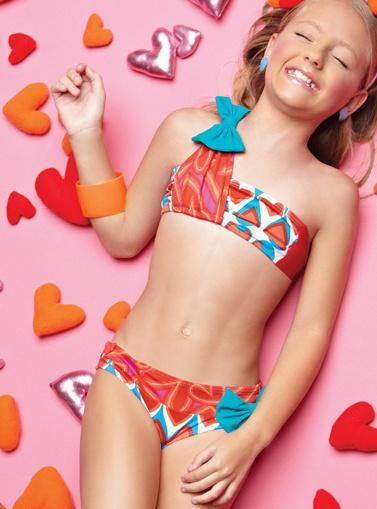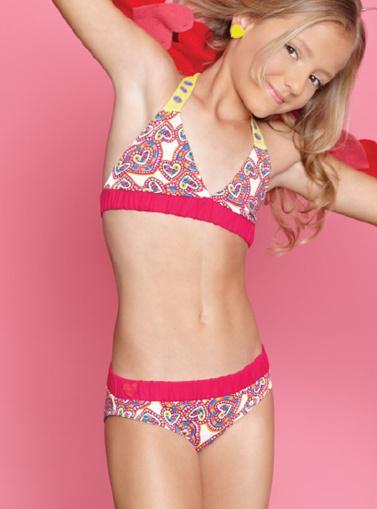The first image is the image on the left, the second image is the image on the right. Examine the images to the left and right. Is the description "A girl is laying down in colorful hearts" accurate? Answer yes or no. Yes. 